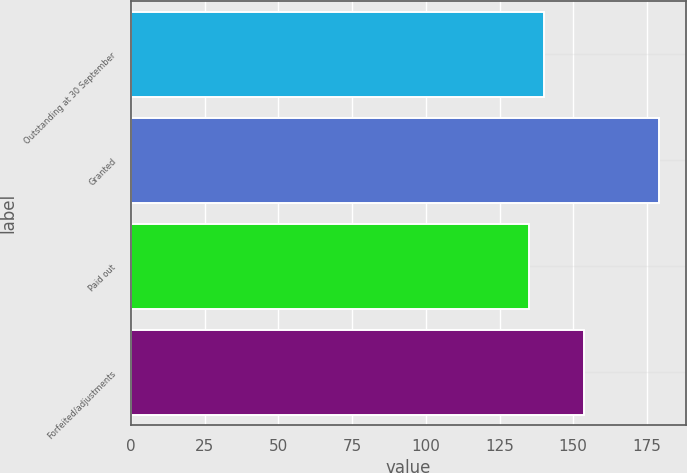Convert chart to OTSL. <chart><loc_0><loc_0><loc_500><loc_500><bar_chart><fcel>Outstanding at 30 September<fcel>Granted<fcel>Paid out<fcel>Forfeited/adjustments<nl><fcel>140.18<fcel>179.21<fcel>134.99<fcel>153.57<nl></chart> 